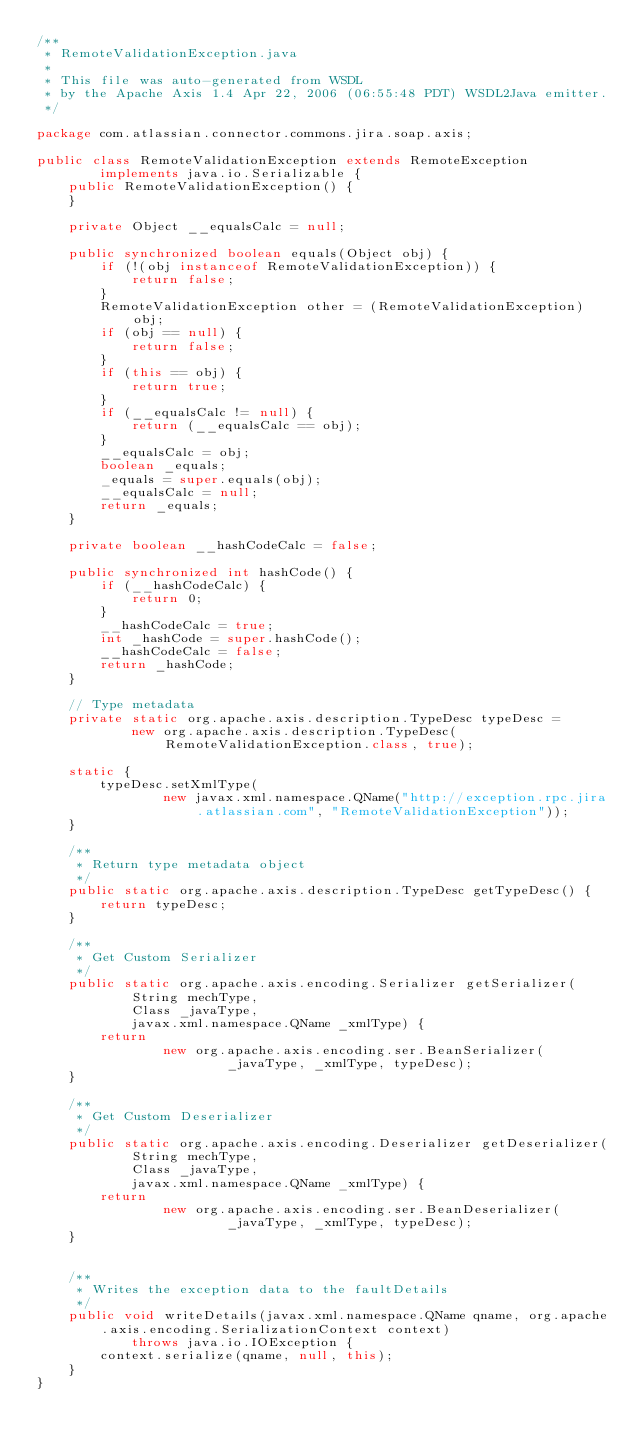Convert code to text. <code><loc_0><loc_0><loc_500><loc_500><_Java_>/**
 * RemoteValidationException.java
 *
 * This file was auto-generated from WSDL
 * by the Apache Axis 1.4 Apr 22, 2006 (06:55:48 PDT) WSDL2Java emitter.
 */

package com.atlassian.connector.commons.jira.soap.axis;

public class RemoteValidationException extends RemoteException
		implements java.io.Serializable {
	public RemoteValidationException() {
	}

	private Object __equalsCalc = null;

	public synchronized boolean equals(Object obj) {
		if (!(obj instanceof RemoteValidationException)) {
			return false;
		}
		RemoteValidationException other = (RemoteValidationException) obj;
		if (obj == null) {
			return false;
		}
		if (this == obj) {
			return true;
		}
		if (__equalsCalc != null) {
			return (__equalsCalc == obj);
		}
		__equalsCalc = obj;
		boolean _equals;
		_equals = super.equals(obj);
		__equalsCalc = null;
		return _equals;
	}

	private boolean __hashCodeCalc = false;

	public synchronized int hashCode() {
		if (__hashCodeCalc) {
			return 0;
		}
		__hashCodeCalc = true;
		int _hashCode = super.hashCode();
		__hashCodeCalc = false;
		return _hashCode;
	}

	// Type metadata
	private static org.apache.axis.description.TypeDesc typeDesc =
			new org.apache.axis.description.TypeDesc(RemoteValidationException.class, true);

	static {
		typeDesc.setXmlType(
				new javax.xml.namespace.QName("http://exception.rpc.jira.atlassian.com", "RemoteValidationException"));
	}

	/**
	 * Return type metadata object
	 */
	public static org.apache.axis.description.TypeDesc getTypeDesc() {
		return typeDesc;
	}

	/**
	 * Get Custom Serializer
	 */
	public static org.apache.axis.encoding.Serializer getSerializer(
			String mechType,
			Class _javaType,
			javax.xml.namespace.QName _xmlType) {
		return
				new org.apache.axis.encoding.ser.BeanSerializer(
						_javaType, _xmlType, typeDesc);
	}

	/**
	 * Get Custom Deserializer
	 */
	public static org.apache.axis.encoding.Deserializer getDeserializer(
			String mechType,
			Class _javaType,
			javax.xml.namespace.QName _xmlType) {
		return
				new org.apache.axis.encoding.ser.BeanDeserializer(
						_javaType, _xmlType, typeDesc);
	}


	/**
	 * Writes the exception data to the faultDetails
	 */
	public void writeDetails(javax.xml.namespace.QName qname, org.apache.axis.encoding.SerializationContext context)
			throws java.io.IOException {
		context.serialize(qname, null, this);
	}
}
</code> 